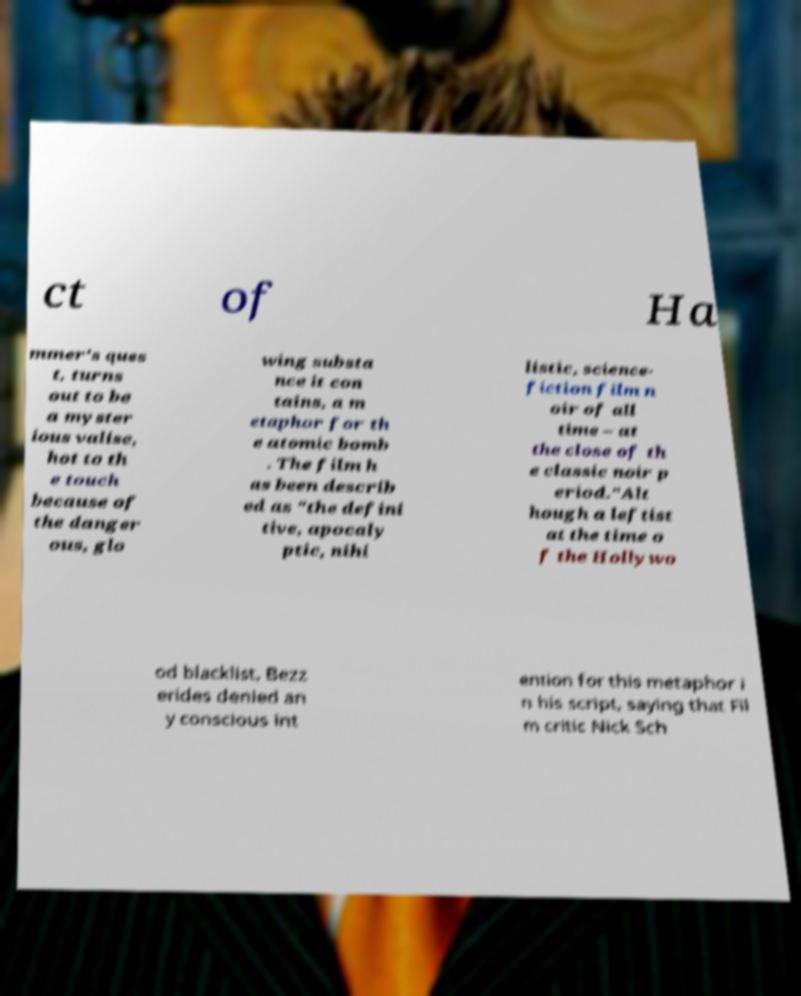Could you extract and type out the text from this image? ct of Ha mmer's ques t, turns out to be a myster ious valise, hot to th e touch because of the danger ous, glo wing substa nce it con tains, a m etaphor for th e atomic bomb . The film h as been describ ed as "the defini tive, apocaly ptic, nihi listic, science- fiction film n oir of all time – at the close of th e classic noir p eriod."Alt hough a leftist at the time o f the Hollywo od blacklist, Bezz erides denied an y conscious int ention for this metaphor i n his script, saying that Fil m critic Nick Sch 